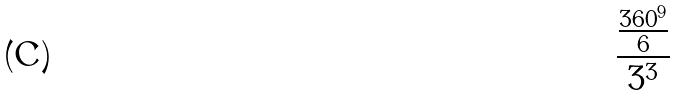Convert formula to latex. <formula><loc_0><loc_0><loc_500><loc_500>\frac { \frac { 3 6 0 ^ { 9 } } { 6 } } { 3 ^ { 3 } }</formula> 